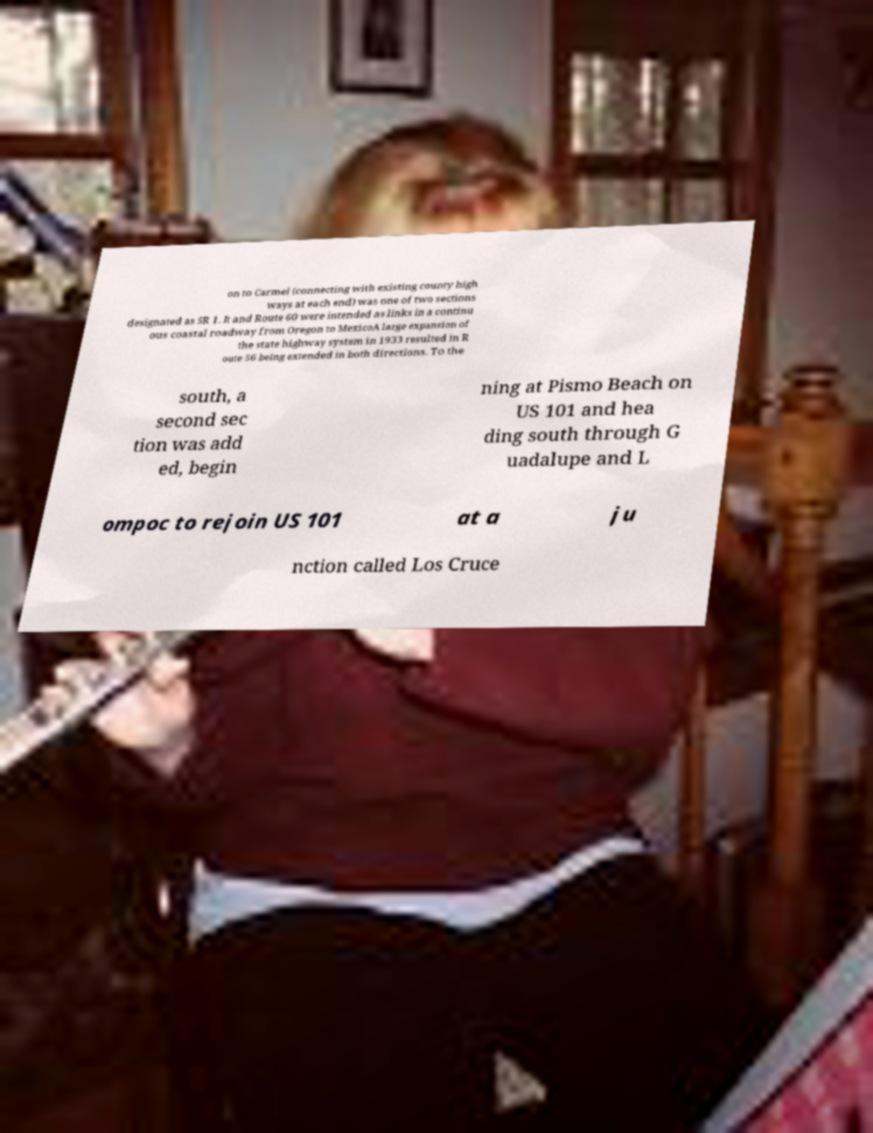Can you read and provide the text displayed in the image?This photo seems to have some interesting text. Can you extract and type it out for me? on to Carmel (connecting with existing county high ways at each end) was one of two sections designated as SR 1. It and Route 60 were intended as links in a continu ous coastal roadway from Oregon to MexicoA large expansion of the state highway system in 1933 resulted in R oute 56 being extended in both directions. To the south, a second sec tion was add ed, begin ning at Pismo Beach on US 101 and hea ding south through G uadalupe and L ompoc to rejoin US 101 at a ju nction called Los Cruce 